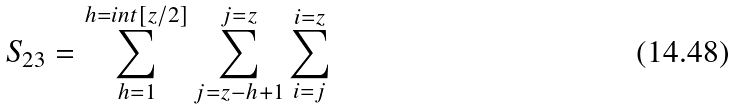Convert formula to latex. <formula><loc_0><loc_0><loc_500><loc_500>S _ { 2 3 } = \sum _ { h = 1 } ^ { h = i n t [ z / 2 ] } \sum _ { j = z - h + 1 } ^ { j = z } \sum _ { i = j } ^ { i = z }</formula> 